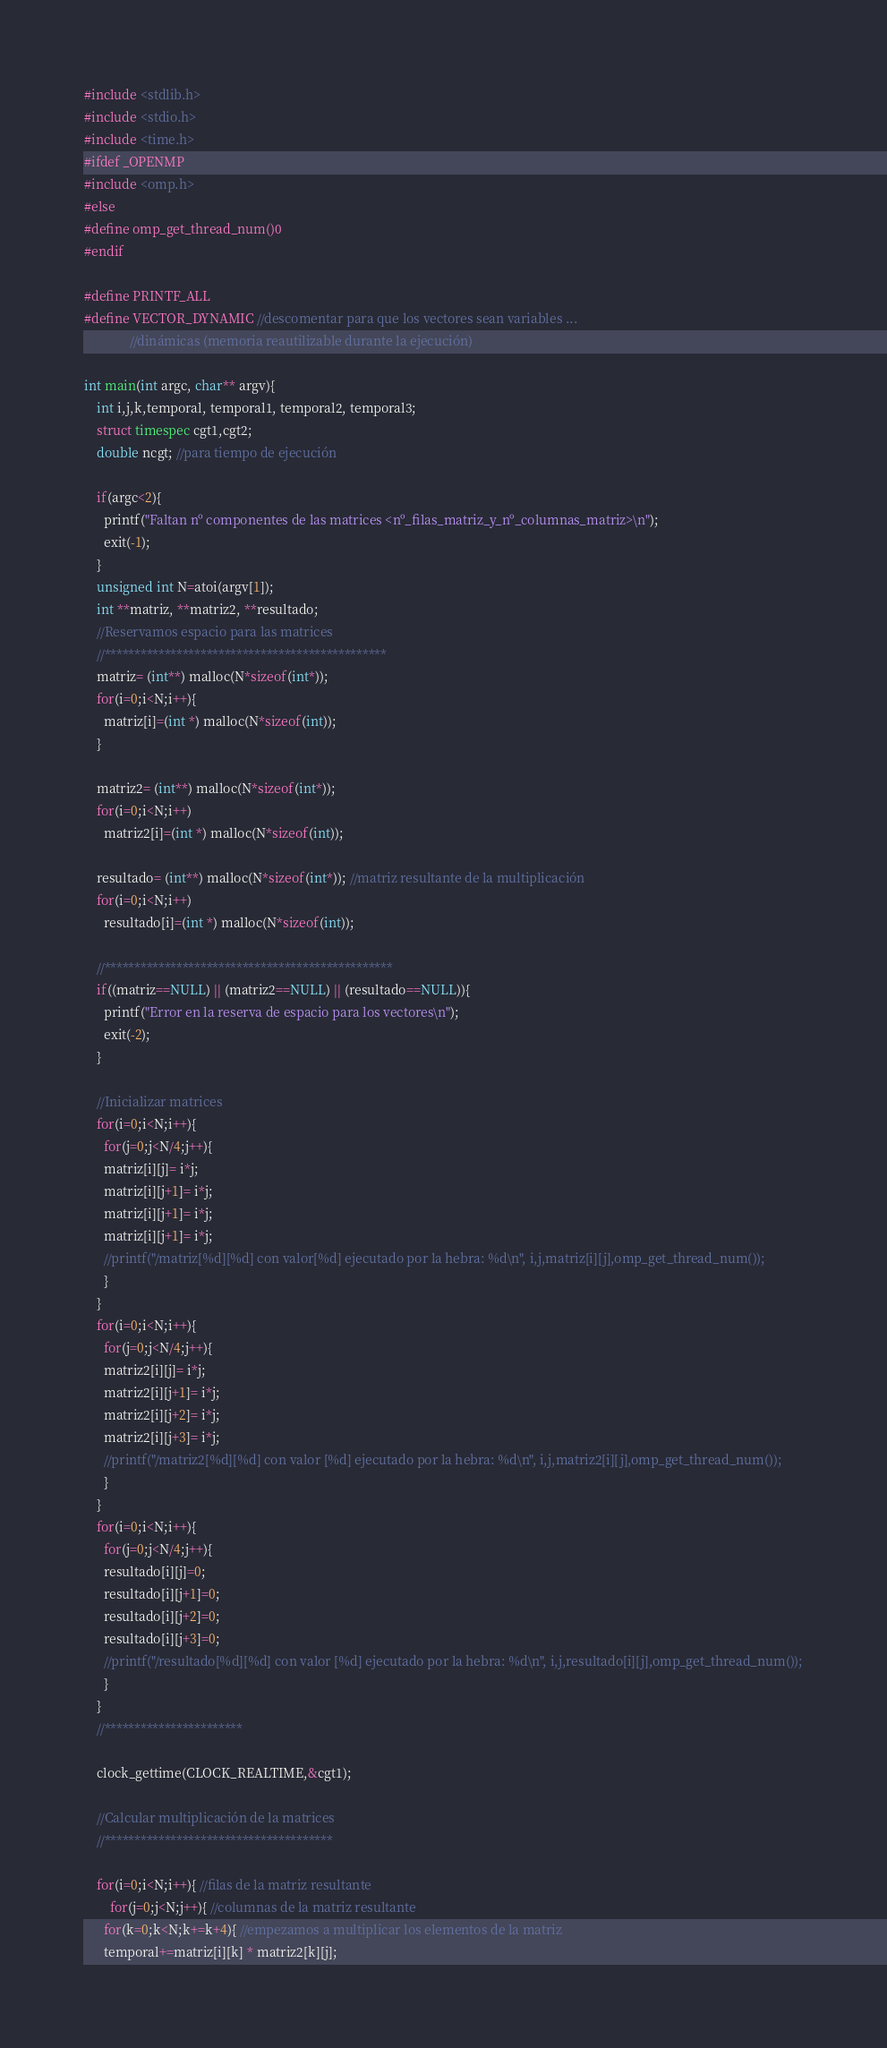Convert code to text. <code><loc_0><loc_0><loc_500><loc_500><_C_>#include <stdlib.h>
#include <stdio.h>
#include <time.h>
#ifdef _OPENMP
#include <omp.h>
#else
#define omp_get_thread_num()0
#endif

#define PRINTF_ALL
#define VECTOR_DYNAMIC //descomentar para que los vectores sean variables ...
		      //dinámicas (memoria reautilizable durante la ejecución)
		      
int main(int argc, char** argv){
    int i,j,k,temporal, temporal1, temporal2, temporal3;
    struct timespec cgt1,cgt2;
    double ncgt; //para tiempo de ejecución
 
    if(argc<2){
      printf("Faltan nº componentes de las matrices <nº_filas_matriz_y_nº_columnas_matriz>\n");
      exit(-1);
    }
    unsigned int N=atoi(argv[1]);
    int **matriz, **matriz2, **resultado;
    //Reservamos espacio para las matrices
    //***********************************************
    matriz= (int**) malloc(N*sizeof(int*));
    for(i=0;i<N;i++){
      matriz[i]=(int *) malloc(N*sizeof(int));
    }

    matriz2= (int**) malloc(N*sizeof(int*));
    for(i=0;i<N;i++)
      matriz2[i]=(int *) malloc(N*sizeof(int));

    resultado= (int**) malloc(N*sizeof(int*)); //matriz resultante de la multiplicación
    for(i=0;i<N;i++)
      resultado[i]=(int *) malloc(N*sizeof(int));    
    
    //************************************************
    if((matriz==NULL) || (matriz2==NULL) || (resultado==NULL)){
      printf("Error en la reserva de espacio para los vectores\n");
      exit(-2);
    }
    
    //Inicializar matrices
    for(i=0;i<N;i++){
      for(j=0;j<N/4;j++){
	  matriz[i][j]= i*j;
	  matriz[i][j+1]= i*j;
	  matriz[i][j+1]= i*j;
	  matriz[i][j+1]= i*j;
	  //printf("/matriz[%d][%d] con valor[%d] ejecutado por la hebra: %d\n", i,j,matriz[i][j],omp_get_thread_num());
      }
    }
    for(i=0;i<N;i++){
      for(j=0;j<N/4;j++){
	  matriz2[i][j]= i*j;
	  matriz2[i][j+1]= i*j;
	  matriz2[i][j+2]= i*j;
	  matriz2[i][j+3]= i*j;
	  //printf("/matriz2[%d][%d] con valor [%d] ejecutado por la hebra: %d\n", i,j,matriz2[i][j],omp_get_thread_num());
      }
    }
    for(i=0;i<N;i++){
      for(j=0;j<N/4;j++){
	  resultado[i][j]=0;
	  resultado[i][j+1]=0;
	  resultado[i][j+2]=0;
	  resultado[i][j+3]=0;
	  //printf("/resultado[%d][%d] con valor [%d] ejecutado por la hebra: %d\n", i,j,resultado[i][j],omp_get_thread_num());
      }
    }   
    //***********************
    
    clock_gettime(CLOCK_REALTIME,&cgt1);
    
    //Calcular multiplicación de la matrices
    //**************************************
    
    for(i=0;i<N;i++){ //filas de la matriz resultante
      	for(j=0;j<N;j++){ //columnas de la matriz resultante
	  for(k=0;k<N;k+=k+4){ //empezamos a multiplicar los elementos de la matriz
	  temporal+=matriz[i][k] * matriz2[k][j];</code> 